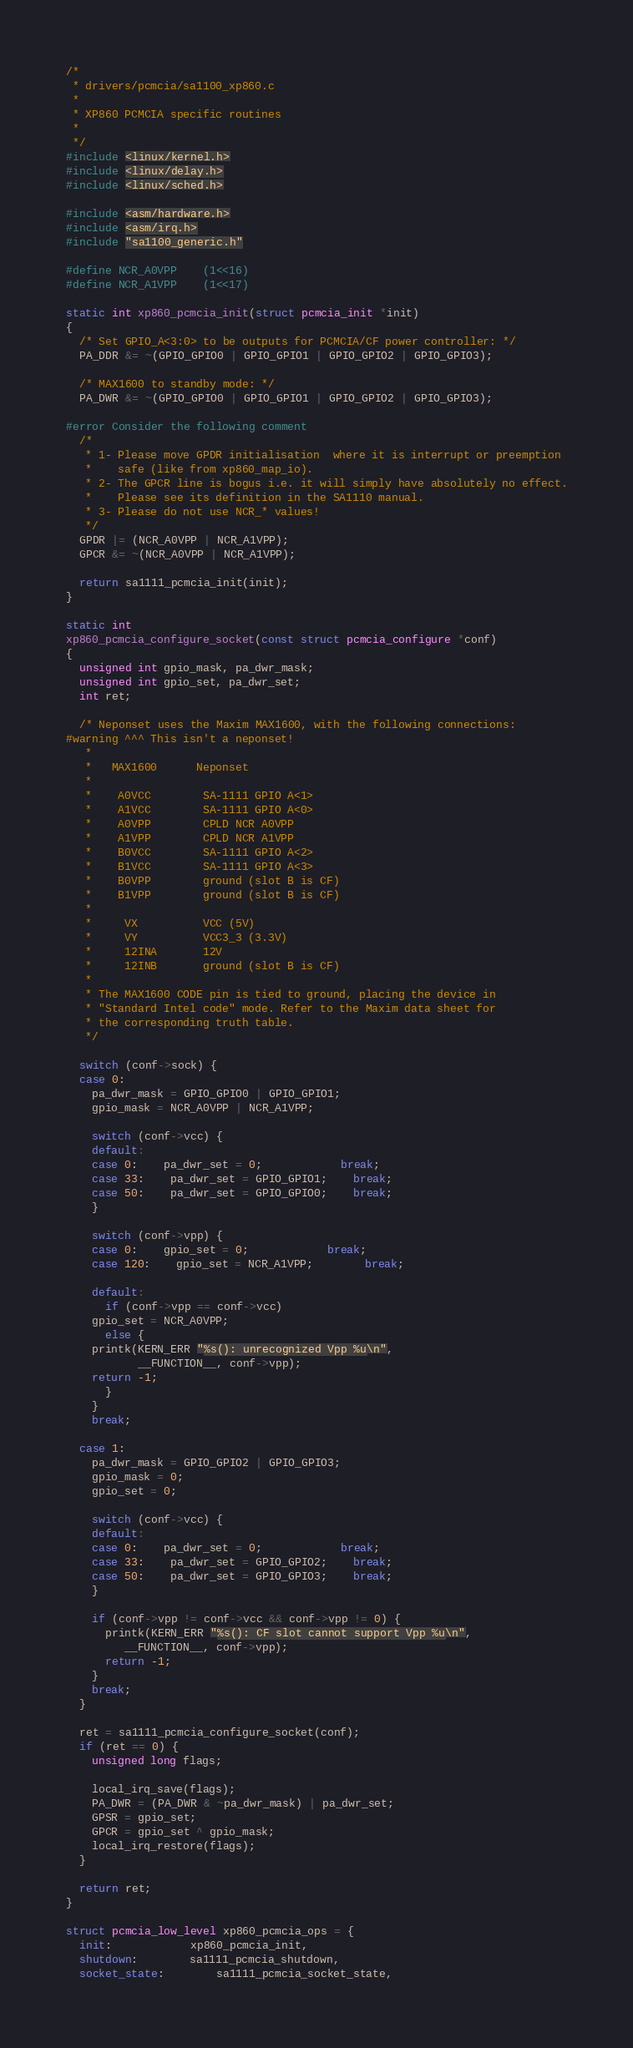<code> <loc_0><loc_0><loc_500><loc_500><_C_>/*
 * drivers/pcmcia/sa1100_xp860.c
 *
 * XP860 PCMCIA specific routines
 *
 */
#include <linux/kernel.h>
#include <linux/delay.h>
#include <linux/sched.h>

#include <asm/hardware.h>
#include <asm/irq.h>
#include "sa1100_generic.h"

#define NCR_A0VPP	(1<<16)
#define NCR_A1VPP	(1<<17)

static int xp860_pcmcia_init(struct pcmcia_init *init)
{
  /* Set GPIO_A<3:0> to be outputs for PCMCIA/CF power controller: */
  PA_DDR &= ~(GPIO_GPIO0 | GPIO_GPIO1 | GPIO_GPIO2 | GPIO_GPIO3);
  
  /* MAX1600 to standby mode: */
  PA_DWR &= ~(GPIO_GPIO0 | GPIO_GPIO1 | GPIO_GPIO2 | GPIO_GPIO3);

#error Consider the following comment
  /*
   * 1- Please move GPDR initialisation  where it is interrupt or preemption
   *    safe (like from xp860_map_io).
   * 2- The GPCR line is bogus i.e. it will simply have absolutely no effect.
   *    Please see its definition in the SA1110 manual.
   * 3- Please do not use NCR_* values!
   */
  GPDR |= (NCR_A0VPP | NCR_A1VPP);
  GPCR &= ~(NCR_A0VPP | NCR_A1VPP);

  return sa1111_pcmcia_init(init);
}

static int
xp860_pcmcia_configure_socket(const struct pcmcia_configure *conf)
{
  unsigned int gpio_mask, pa_dwr_mask;
  unsigned int gpio_set, pa_dwr_set;
  int ret;

  /* Neponset uses the Maxim MAX1600, with the following connections:
#warning ^^^ This isn't a neponset!
   *
   *   MAX1600      Neponset
   *
   *    A0VCC        SA-1111 GPIO A<1>
   *    A1VCC        SA-1111 GPIO A<0>
   *    A0VPP        CPLD NCR A0VPP
   *    A1VPP        CPLD NCR A1VPP
   *    B0VCC        SA-1111 GPIO A<2>
   *    B1VCC        SA-1111 GPIO A<3>
   *    B0VPP        ground (slot B is CF)
   *    B1VPP        ground (slot B is CF)
   *
   *     VX          VCC (5V)
   *     VY          VCC3_3 (3.3V)
   *     12INA       12V
   *     12INB       ground (slot B is CF)
   *
   * The MAX1600 CODE pin is tied to ground, placing the device in 
   * "Standard Intel code" mode. Refer to the Maxim data sheet for
   * the corresponding truth table.
   */

  switch (conf->sock) {
  case 0:
    pa_dwr_mask = GPIO_GPIO0 | GPIO_GPIO1;
    gpio_mask = NCR_A0VPP | NCR_A1VPP;

    switch (conf->vcc) {
    default:
    case 0:	pa_dwr_set = 0;			break;
    case 33:	pa_dwr_set = GPIO_GPIO1;	break;
    case 50:	pa_dwr_set = GPIO_GPIO0;	break;
    }

    switch (conf->vpp) {
    case 0:	gpio_set = 0;			break;
    case 120:	gpio_set = NCR_A1VPP;		break;

    default:
      if (conf->vpp == conf->vcc)
	gpio_set = NCR_A0VPP;
      else {
	printk(KERN_ERR "%s(): unrecognized Vpp %u\n",
	       __FUNCTION__, conf->vpp);
	return -1;
      }
    }
    break;

  case 1:
    pa_dwr_mask = GPIO_GPIO2 | GPIO_GPIO3;
    gpio_mask = 0;
    gpio_set = 0;

    switch (conf->vcc) {
    default:
    case 0:	pa_dwr_set = 0;			break;
    case 33:	pa_dwr_set = GPIO_GPIO2;	break;
    case 50:	pa_dwr_set = GPIO_GPIO3;	break;
    }

    if (conf->vpp != conf->vcc && conf->vpp != 0) {
      printk(KERN_ERR "%s(): CF slot cannot support Vpp %u\n",
	     __FUNCTION__, conf->vpp);
      return -1;
    }
    break;
  }

  ret = sa1111_pcmcia_configure_socket(conf);
  if (ret == 0) {
    unsigned long flags;

    local_irq_save(flags);
    PA_DWR = (PA_DWR & ~pa_dwr_mask) | pa_dwr_set;
    GPSR = gpio_set;
    GPCR = gpio_set ^ gpio_mask;
    local_irq_restore(flags);
  }

  return ret;
}

struct pcmcia_low_level xp860_pcmcia_ops = { 
  init:			xp860_pcmcia_init,
  shutdown:		sa1111_pcmcia_shutdown,
  socket_state:		sa1111_pcmcia_socket_state,</code> 